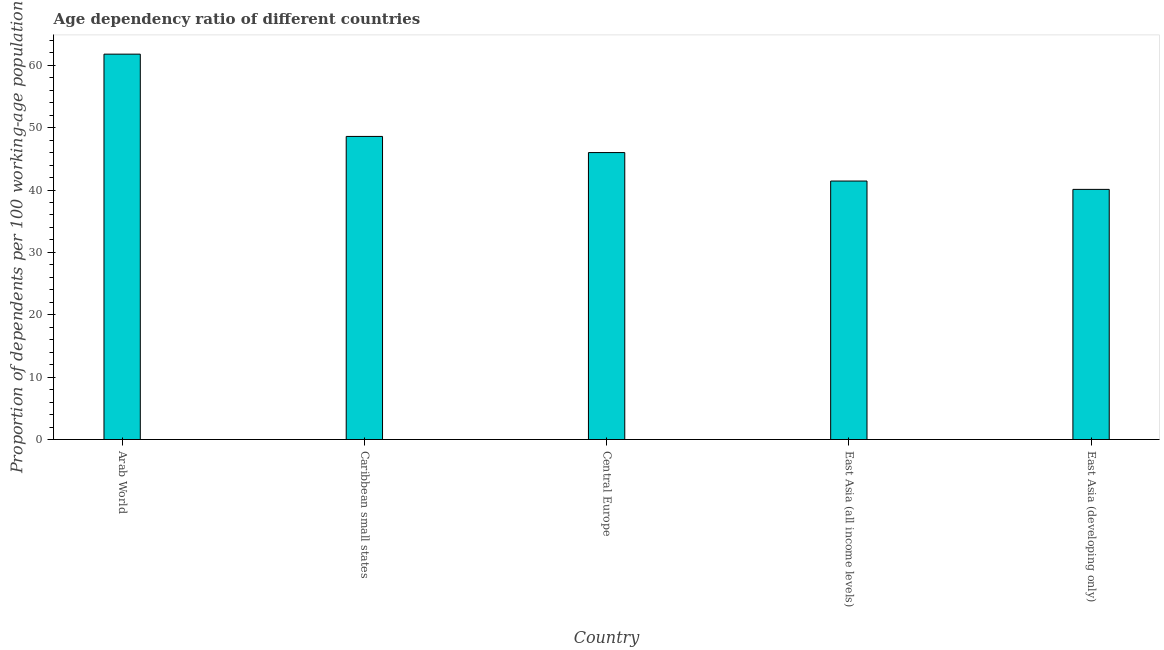Does the graph contain any zero values?
Your answer should be very brief. No. Does the graph contain grids?
Give a very brief answer. No. What is the title of the graph?
Provide a short and direct response. Age dependency ratio of different countries. What is the label or title of the Y-axis?
Offer a very short reply. Proportion of dependents per 100 working-age population. What is the age dependency ratio in Caribbean small states?
Give a very brief answer. 48.6. Across all countries, what is the maximum age dependency ratio?
Your answer should be compact. 61.79. Across all countries, what is the minimum age dependency ratio?
Ensure brevity in your answer.  40.11. In which country was the age dependency ratio maximum?
Offer a terse response. Arab World. In which country was the age dependency ratio minimum?
Offer a very short reply. East Asia (developing only). What is the sum of the age dependency ratio?
Your answer should be compact. 237.95. What is the difference between the age dependency ratio in Arab World and East Asia (developing only)?
Provide a short and direct response. 21.68. What is the average age dependency ratio per country?
Offer a very short reply. 47.59. What is the median age dependency ratio?
Your answer should be compact. 46.01. What is the ratio of the age dependency ratio in Arab World to that in Caribbean small states?
Make the answer very short. 1.27. Is the difference between the age dependency ratio in Arab World and East Asia (developing only) greater than the difference between any two countries?
Provide a short and direct response. Yes. What is the difference between the highest and the second highest age dependency ratio?
Ensure brevity in your answer.  13.19. What is the difference between the highest and the lowest age dependency ratio?
Your response must be concise. 21.68. Are the values on the major ticks of Y-axis written in scientific E-notation?
Provide a short and direct response. No. What is the Proportion of dependents per 100 working-age population of Arab World?
Your response must be concise. 61.79. What is the Proportion of dependents per 100 working-age population in Caribbean small states?
Your answer should be very brief. 48.6. What is the Proportion of dependents per 100 working-age population of Central Europe?
Your answer should be compact. 46.01. What is the Proportion of dependents per 100 working-age population in East Asia (all income levels)?
Give a very brief answer. 41.44. What is the Proportion of dependents per 100 working-age population of East Asia (developing only)?
Your answer should be very brief. 40.11. What is the difference between the Proportion of dependents per 100 working-age population in Arab World and Caribbean small states?
Provide a succinct answer. 13.19. What is the difference between the Proportion of dependents per 100 working-age population in Arab World and Central Europe?
Keep it short and to the point. 15.78. What is the difference between the Proportion of dependents per 100 working-age population in Arab World and East Asia (all income levels)?
Give a very brief answer. 20.35. What is the difference between the Proportion of dependents per 100 working-age population in Arab World and East Asia (developing only)?
Give a very brief answer. 21.68. What is the difference between the Proportion of dependents per 100 working-age population in Caribbean small states and Central Europe?
Provide a short and direct response. 2.59. What is the difference between the Proportion of dependents per 100 working-age population in Caribbean small states and East Asia (all income levels)?
Offer a terse response. 7.15. What is the difference between the Proportion of dependents per 100 working-age population in Caribbean small states and East Asia (developing only)?
Offer a very short reply. 8.49. What is the difference between the Proportion of dependents per 100 working-age population in Central Europe and East Asia (all income levels)?
Ensure brevity in your answer.  4.57. What is the difference between the Proportion of dependents per 100 working-age population in Central Europe and East Asia (developing only)?
Keep it short and to the point. 5.9. What is the difference between the Proportion of dependents per 100 working-age population in East Asia (all income levels) and East Asia (developing only)?
Make the answer very short. 1.34. What is the ratio of the Proportion of dependents per 100 working-age population in Arab World to that in Caribbean small states?
Ensure brevity in your answer.  1.27. What is the ratio of the Proportion of dependents per 100 working-age population in Arab World to that in Central Europe?
Offer a very short reply. 1.34. What is the ratio of the Proportion of dependents per 100 working-age population in Arab World to that in East Asia (all income levels)?
Offer a terse response. 1.49. What is the ratio of the Proportion of dependents per 100 working-age population in Arab World to that in East Asia (developing only)?
Keep it short and to the point. 1.54. What is the ratio of the Proportion of dependents per 100 working-age population in Caribbean small states to that in Central Europe?
Your answer should be compact. 1.06. What is the ratio of the Proportion of dependents per 100 working-age population in Caribbean small states to that in East Asia (all income levels)?
Ensure brevity in your answer.  1.17. What is the ratio of the Proportion of dependents per 100 working-age population in Caribbean small states to that in East Asia (developing only)?
Provide a short and direct response. 1.21. What is the ratio of the Proportion of dependents per 100 working-age population in Central Europe to that in East Asia (all income levels)?
Your answer should be very brief. 1.11. What is the ratio of the Proportion of dependents per 100 working-age population in Central Europe to that in East Asia (developing only)?
Your answer should be very brief. 1.15. What is the ratio of the Proportion of dependents per 100 working-age population in East Asia (all income levels) to that in East Asia (developing only)?
Your answer should be compact. 1.03. 